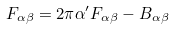<formula> <loc_0><loc_0><loc_500><loc_500>F _ { \alpha \beta } = 2 \pi \alpha ^ { \prime } F _ { \alpha \beta } - B _ { \alpha \beta }</formula> 